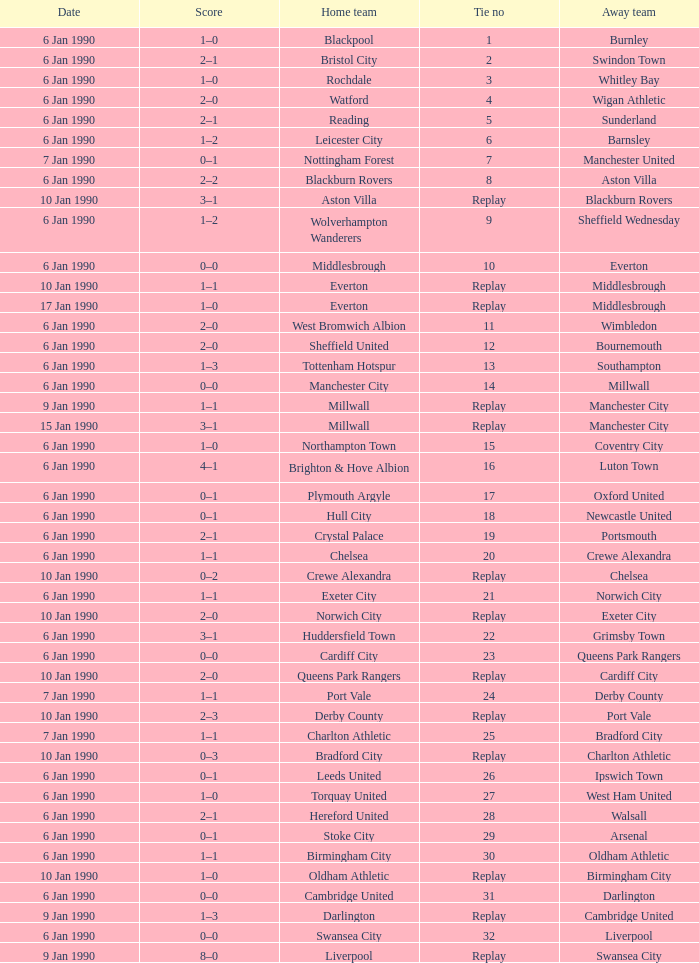What date did home team liverpool play? 9 Jan 1990. 